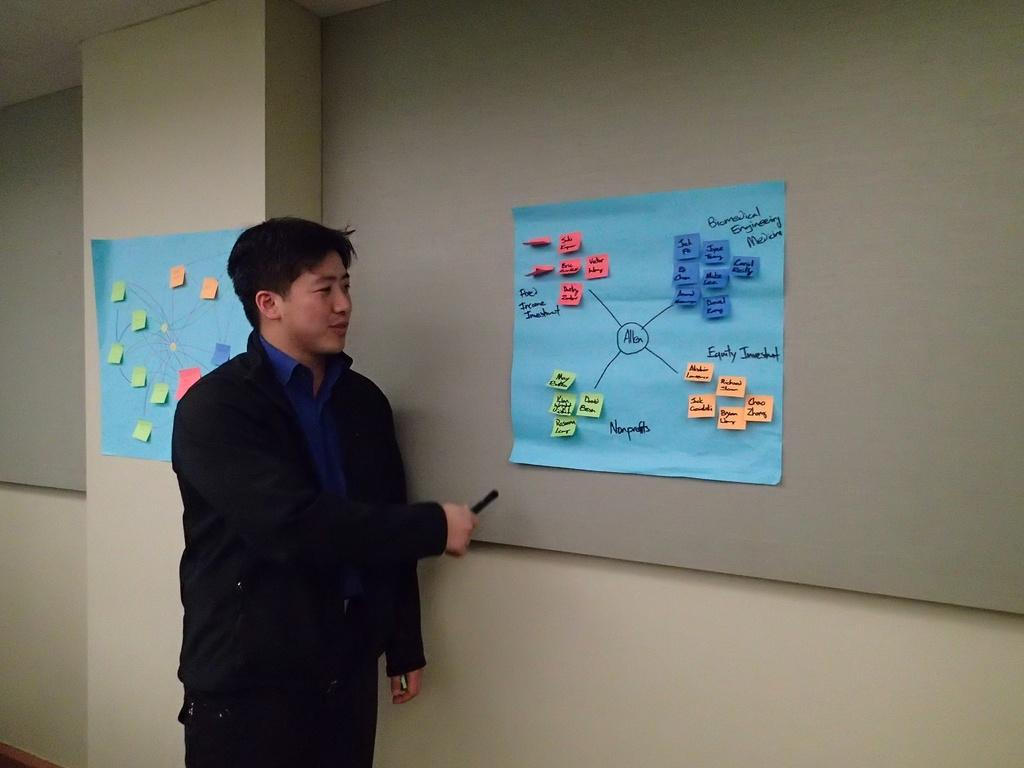What can be seen in the image? There is a person in the image. Can you describe the person's attire? The person is wearing clothes. What is the person holding in his hand? The person is holding an object in his hand. What is on the wall in the image? There are charts on the wall in the image. What type of nail is being hammered into the street in the image? There is no nail or street present in the image. 